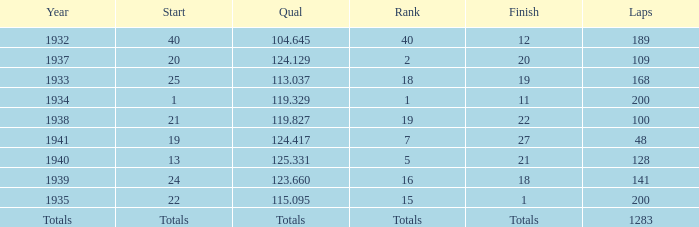What year did he start at 13? 1940.0. 